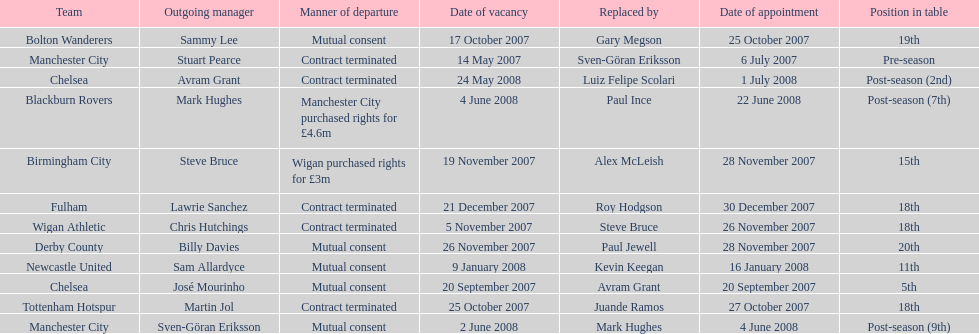What team is listed after manchester city? Chelsea. 